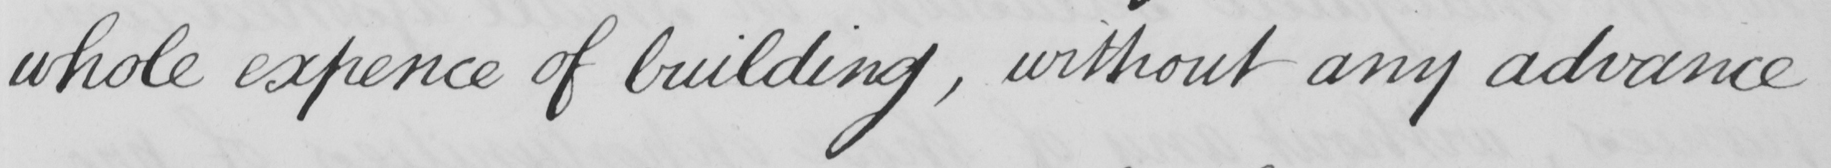What text is written in this handwritten line? whole expence of building , without any advance 